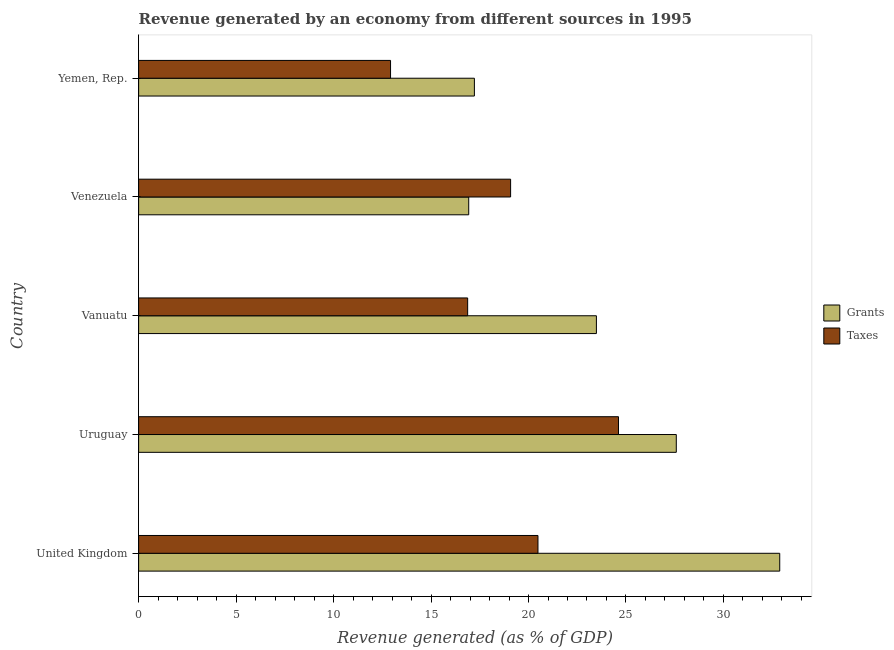How many different coloured bars are there?
Your answer should be compact. 2. How many groups of bars are there?
Your answer should be very brief. 5. Are the number of bars per tick equal to the number of legend labels?
Make the answer very short. Yes. What is the label of the 3rd group of bars from the top?
Give a very brief answer. Vanuatu. In how many cases, is the number of bars for a given country not equal to the number of legend labels?
Offer a terse response. 0. What is the revenue generated by taxes in Venezuela?
Provide a succinct answer. 19.08. Across all countries, what is the maximum revenue generated by grants?
Offer a terse response. 32.89. Across all countries, what is the minimum revenue generated by taxes?
Your answer should be very brief. 12.92. In which country was the revenue generated by taxes maximum?
Your answer should be very brief. Uruguay. In which country was the revenue generated by taxes minimum?
Offer a terse response. Yemen, Rep. What is the total revenue generated by taxes in the graph?
Offer a terse response. 93.99. What is the difference between the revenue generated by taxes in Uruguay and that in Venezuela?
Offer a terse response. 5.53. What is the difference between the revenue generated by grants in Yemen, Rep. and the revenue generated by taxes in Venezuela?
Your response must be concise. -1.86. What is the average revenue generated by grants per country?
Provide a short and direct response. 23.62. What is the difference between the revenue generated by grants and revenue generated by taxes in Venezuela?
Your answer should be very brief. -2.15. What is the ratio of the revenue generated by taxes in Uruguay to that in Vanuatu?
Ensure brevity in your answer.  1.46. Is the difference between the revenue generated by grants in United Kingdom and Uruguay greater than the difference between the revenue generated by taxes in United Kingdom and Uruguay?
Provide a succinct answer. Yes. What is the difference between the highest and the second highest revenue generated by taxes?
Provide a short and direct response. 4.13. What is the difference between the highest and the lowest revenue generated by grants?
Offer a terse response. 15.95. In how many countries, is the revenue generated by grants greater than the average revenue generated by grants taken over all countries?
Your response must be concise. 2. Is the sum of the revenue generated by taxes in Uruguay and Yemen, Rep. greater than the maximum revenue generated by grants across all countries?
Your answer should be very brief. Yes. What does the 2nd bar from the top in Yemen, Rep. represents?
Your answer should be compact. Grants. What does the 1st bar from the bottom in United Kingdom represents?
Provide a short and direct response. Grants. How many countries are there in the graph?
Your answer should be compact. 5. Are the values on the major ticks of X-axis written in scientific E-notation?
Offer a terse response. No. Does the graph contain any zero values?
Keep it short and to the point. No. Does the graph contain grids?
Keep it short and to the point. No. Where does the legend appear in the graph?
Give a very brief answer. Center right. How are the legend labels stacked?
Provide a succinct answer. Vertical. What is the title of the graph?
Offer a terse response. Revenue generated by an economy from different sources in 1995. Does "Travel Items" appear as one of the legend labels in the graph?
Provide a short and direct response. No. What is the label or title of the X-axis?
Offer a very short reply. Revenue generated (as % of GDP). What is the Revenue generated (as % of GDP) of Grants in United Kingdom?
Your response must be concise. 32.89. What is the Revenue generated (as % of GDP) of Taxes in United Kingdom?
Keep it short and to the point. 20.49. What is the Revenue generated (as % of GDP) of Grants in Uruguay?
Your answer should be compact. 27.58. What is the Revenue generated (as % of GDP) in Taxes in Uruguay?
Your answer should be compact. 24.62. What is the Revenue generated (as % of GDP) in Grants in Vanuatu?
Your response must be concise. 23.48. What is the Revenue generated (as % of GDP) in Taxes in Vanuatu?
Provide a short and direct response. 16.88. What is the Revenue generated (as % of GDP) of Grants in Venezuela?
Offer a terse response. 16.93. What is the Revenue generated (as % of GDP) in Taxes in Venezuela?
Make the answer very short. 19.08. What is the Revenue generated (as % of GDP) in Grants in Yemen, Rep.?
Provide a succinct answer. 17.22. What is the Revenue generated (as % of GDP) in Taxes in Yemen, Rep.?
Ensure brevity in your answer.  12.92. Across all countries, what is the maximum Revenue generated (as % of GDP) in Grants?
Ensure brevity in your answer.  32.89. Across all countries, what is the maximum Revenue generated (as % of GDP) of Taxes?
Offer a very short reply. 24.62. Across all countries, what is the minimum Revenue generated (as % of GDP) in Grants?
Your response must be concise. 16.93. Across all countries, what is the minimum Revenue generated (as % of GDP) of Taxes?
Keep it short and to the point. 12.92. What is the total Revenue generated (as % of GDP) of Grants in the graph?
Provide a short and direct response. 118.11. What is the total Revenue generated (as % of GDP) in Taxes in the graph?
Keep it short and to the point. 93.99. What is the difference between the Revenue generated (as % of GDP) in Grants in United Kingdom and that in Uruguay?
Your response must be concise. 5.31. What is the difference between the Revenue generated (as % of GDP) of Taxes in United Kingdom and that in Uruguay?
Your response must be concise. -4.13. What is the difference between the Revenue generated (as % of GDP) of Grants in United Kingdom and that in Vanuatu?
Your response must be concise. 9.4. What is the difference between the Revenue generated (as % of GDP) of Taxes in United Kingdom and that in Vanuatu?
Offer a very short reply. 3.61. What is the difference between the Revenue generated (as % of GDP) of Grants in United Kingdom and that in Venezuela?
Make the answer very short. 15.95. What is the difference between the Revenue generated (as % of GDP) of Taxes in United Kingdom and that in Venezuela?
Provide a succinct answer. 1.4. What is the difference between the Revenue generated (as % of GDP) in Grants in United Kingdom and that in Yemen, Rep.?
Offer a very short reply. 15.66. What is the difference between the Revenue generated (as % of GDP) of Taxes in United Kingdom and that in Yemen, Rep.?
Provide a short and direct response. 7.56. What is the difference between the Revenue generated (as % of GDP) in Grants in Uruguay and that in Vanuatu?
Keep it short and to the point. 4.1. What is the difference between the Revenue generated (as % of GDP) in Taxes in Uruguay and that in Vanuatu?
Offer a terse response. 7.74. What is the difference between the Revenue generated (as % of GDP) of Grants in Uruguay and that in Venezuela?
Your answer should be compact. 10.65. What is the difference between the Revenue generated (as % of GDP) of Taxes in Uruguay and that in Venezuela?
Offer a very short reply. 5.53. What is the difference between the Revenue generated (as % of GDP) of Grants in Uruguay and that in Yemen, Rep.?
Offer a very short reply. 10.36. What is the difference between the Revenue generated (as % of GDP) of Taxes in Uruguay and that in Yemen, Rep.?
Keep it short and to the point. 11.69. What is the difference between the Revenue generated (as % of GDP) in Grants in Vanuatu and that in Venezuela?
Offer a very short reply. 6.55. What is the difference between the Revenue generated (as % of GDP) in Taxes in Vanuatu and that in Venezuela?
Your answer should be compact. -2.2. What is the difference between the Revenue generated (as % of GDP) of Grants in Vanuatu and that in Yemen, Rep.?
Offer a very short reply. 6.26. What is the difference between the Revenue generated (as % of GDP) of Taxes in Vanuatu and that in Yemen, Rep.?
Make the answer very short. 3.96. What is the difference between the Revenue generated (as % of GDP) of Grants in Venezuela and that in Yemen, Rep.?
Your answer should be compact. -0.29. What is the difference between the Revenue generated (as % of GDP) of Taxes in Venezuela and that in Yemen, Rep.?
Your answer should be compact. 6.16. What is the difference between the Revenue generated (as % of GDP) in Grants in United Kingdom and the Revenue generated (as % of GDP) in Taxes in Uruguay?
Give a very brief answer. 8.27. What is the difference between the Revenue generated (as % of GDP) in Grants in United Kingdom and the Revenue generated (as % of GDP) in Taxes in Vanuatu?
Keep it short and to the point. 16.01. What is the difference between the Revenue generated (as % of GDP) in Grants in United Kingdom and the Revenue generated (as % of GDP) in Taxes in Venezuela?
Your answer should be compact. 13.81. What is the difference between the Revenue generated (as % of GDP) of Grants in United Kingdom and the Revenue generated (as % of GDP) of Taxes in Yemen, Rep.?
Your answer should be compact. 19.96. What is the difference between the Revenue generated (as % of GDP) in Grants in Uruguay and the Revenue generated (as % of GDP) in Taxes in Vanuatu?
Give a very brief answer. 10.7. What is the difference between the Revenue generated (as % of GDP) in Grants in Uruguay and the Revenue generated (as % of GDP) in Taxes in Venezuela?
Give a very brief answer. 8.5. What is the difference between the Revenue generated (as % of GDP) in Grants in Uruguay and the Revenue generated (as % of GDP) in Taxes in Yemen, Rep.?
Keep it short and to the point. 14.66. What is the difference between the Revenue generated (as % of GDP) of Grants in Vanuatu and the Revenue generated (as % of GDP) of Taxes in Venezuela?
Your response must be concise. 4.4. What is the difference between the Revenue generated (as % of GDP) of Grants in Vanuatu and the Revenue generated (as % of GDP) of Taxes in Yemen, Rep.?
Provide a short and direct response. 10.56. What is the difference between the Revenue generated (as % of GDP) of Grants in Venezuela and the Revenue generated (as % of GDP) of Taxes in Yemen, Rep.?
Give a very brief answer. 4.01. What is the average Revenue generated (as % of GDP) of Grants per country?
Your answer should be very brief. 23.62. What is the average Revenue generated (as % of GDP) of Taxes per country?
Your answer should be very brief. 18.8. What is the difference between the Revenue generated (as % of GDP) of Grants and Revenue generated (as % of GDP) of Taxes in United Kingdom?
Keep it short and to the point. 12.4. What is the difference between the Revenue generated (as % of GDP) in Grants and Revenue generated (as % of GDP) in Taxes in Uruguay?
Give a very brief answer. 2.97. What is the difference between the Revenue generated (as % of GDP) in Grants and Revenue generated (as % of GDP) in Taxes in Vanuatu?
Give a very brief answer. 6.6. What is the difference between the Revenue generated (as % of GDP) of Grants and Revenue generated (as % of GDP) of Taxes in Venezuela?
Offer a terse response. -2.15. What is the difference between the Revenue generated (as % of GDP) in Grants and Revenue generated (as % of GDP) in Taxes in Yemen, Rep.?
Give a very brief answer. 4.3. What is the ratio of the Revenue generated (as % of GDP) of Grants in United Kingdom to that in Uruguay?
Offer a very short reply. 1.19. What is the ratio of the Revenue generated (as % of GDP) of Taxes in United Kingdom to that in Uruguay?
Provide a short and direct response. 0.83. What is the ratio of the Revenue generated (as % of GDP) in Grants in United Kingdom to that in Vanuatu?
Your response must be concise. 1.4. What is the ratio of the Revenue generated (as % of GDP) in Taxes in United Kingdom to that in Vanuatu?
Provide a short and direct response. 1.21. What is the ratio of the Revenue generated (as % of GDP) of Grants in United Kingdom to that in Venezuela?
Your response must be concise. 1.94. What is the ratio of the Revenue generated (as % of GDP) of Taxes in United Kingdom to that in Venezuela?
Provide a succinct answer. 1.07. What is the ratio of the Revenue generated (as % of GDP) of Grants in United Kingdom to that in Yemen, Rep.?
Your answer should be compact. 1.91. What is the ratio of the Revenue generated (as % of GDP) of Taxes in United Kingdom to that in Yemen, Rep.?
Offer a terse response. 1.59. What is the ratio of the Revenue generated (as % of GDP) in Grants in Uruguay to that in Vanuatu?
Ensure brevity in your answer.  1.17. What is the ratio of the Revenue generated (as % of GDP) of Taxes in Uruguay to that in Vanuatu?
Keep it short and to the point. 1.46. What is the ratio of the Revenue generated (as % of GDP) of Grants in Uruguay to that in Venezuela?
Give a very brief answer. 1.63. What is the ratio of the Revenue generated (as % of GDP) of Taxes in Uruguay to that in Venezuela?
Offer a very short reply. 1.29. What is the ratio of the Revenue generated (as % of GDP) of Grants in Uruguay to that in Yemen, Rep.?
Provide a short and direct response. 1.6. What is the ratio of the Revenue generated (as % of GDP) in Taxes in Uruguay to that in Yemen, Rep.?
Make the answer very short. 1.9. What is the ratio of the Revenue generated (as % of GDP) in Grants in Vanuatu to that in Venezuela?
Your answer should be very brief. 1.39. What is the ratio of the Revenue generated (as % of GDP) of Taxes in Vanuatu to that in Venezuela?
Your response must be concise. 0.88. What is the ratio of the Revenue generated (as % of GDP) of Grants in Vanuatu to that in Yemen, Rep.?
Your response must be concise. 1.36. What is the ratio of the Revenue generated (as % of GDP) of Taxes in Vanuatu to that in Yemen, Rep.?
Keep it short and to the point. 1.31. What is the ratio of the Revenue generated (as % of GDP) in Grants in Venezuela to that in Yemen, Rep.?
Your response must be concise. 0.98. What is the ratio of the Revenue generated (as % of GDP) of Taxes in Venezuela to that in Yemen, Rep.?
Your response must be concise. 1.48. What is the difference between the highest and the second highest Revenue generated (as % of GDP) in Grants?
Your answer should be compact. 5.31. What is the difference between the highest and the second highest Revenue generated (as % of GDP) of Taxes?
Ensure brevity in your answer.  4.13. What is the difference between the highest and the lowest Revenue generated (as % of GDP) of Grants?
Offer a terse response. 15.95. What is the difference between the highest and the lowest Revenue generated (as % of GDP) in Taxes?
Provide a succinct answer. 11.69. 